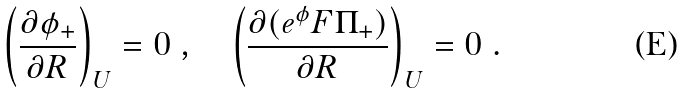Convert formula to latex. <formula><loc_0><loc_0><loc_500><loc_500>\left ( \frac { \partial \phi _ { + } } { \partial R } \right ) _ { U } = 0 \ , \quad \left ( \frac { \partial ( e ^ { \phi } F \Pi _ { + } ) } { \partial R } \right ) _ { U } = 0 \ .</formula> 